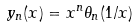Convert formula to latex. <formula><loc_0><loc_0><loc_500><loc_500>y _ { n } ( x ) = x ^ { n } \theta _ { n } ( 1 / x )</formula> 